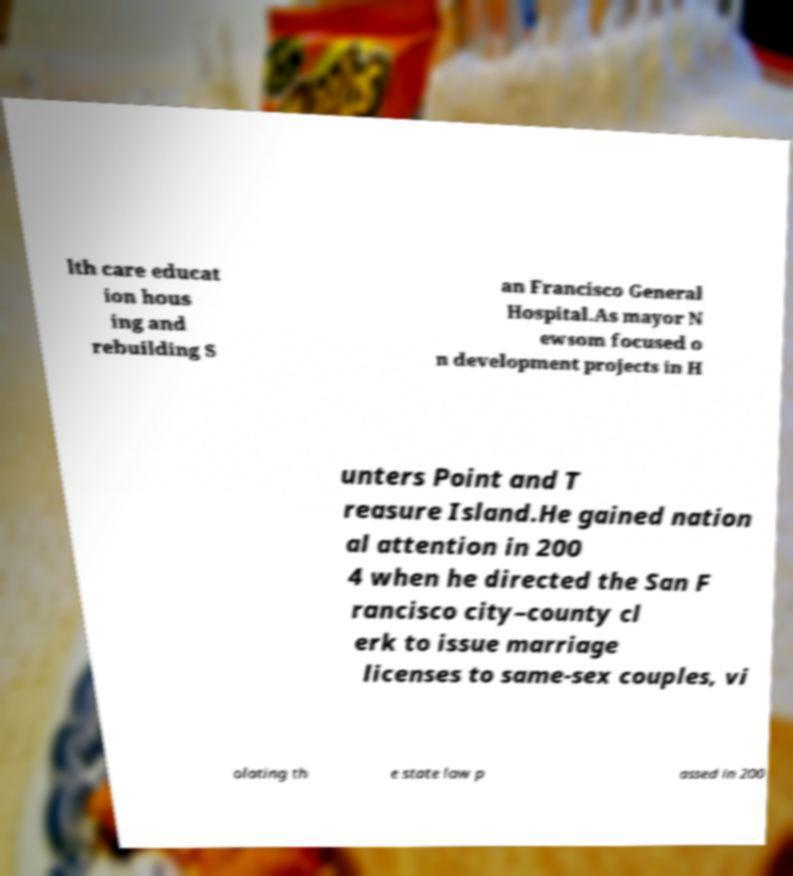What messages or text are displayed in this image? I need them in a readable, typed format. lth care educat ion hous ing and rebuilding S an Francisco General Hospital.As mayor N ewsom focused o n development projects in H unters Point and T reasure Island.He gained nation al attention in 200 4 when he directed the San F rancisco city–county cl erk to issue marriage licenses to same-sex couples, vi olating th e state law p assed in 200 